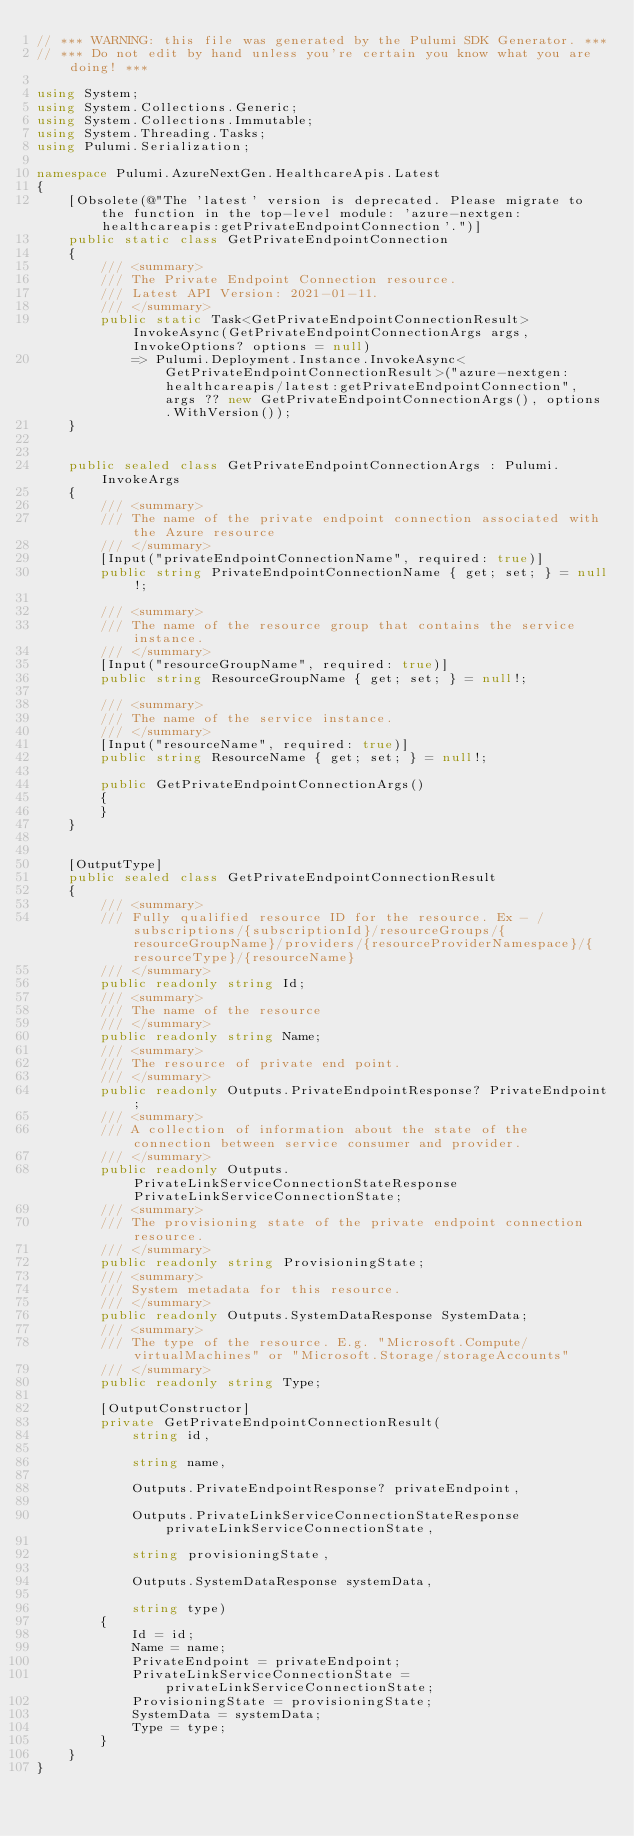<code> <loc_0><loc_0><loc_500><loc_500><_C#_>// *** WARNING: this file was generated by the Pulumi SDK Generator. ***
// *** Do not edit by hand unless you're certain you know what you are doing! ***

using System;
using System.Collections.Generic;
using System.Collections.Immutable;
using System.Threading.Tasks;
using Pulumi.Serialization;

namespace Pulumi.AzureNextGen.HealthcareApis.Latest
{
    [Obsolete(@"The 'latest' version is deprecated. Please migrate to the function in the top-level module: 'azure-nextgen:healthcareapis:getPrivateEndpointConnection'.")]
    public static class GetPrivateEndpointConnection
    {
        /// <summary>
        /// The Private Endpoint Connection resource.
        /// Latest API Version: 2021-01-11.
        /// </summary>
        public static Task<GetPrivateEndpointConnectionResult> InvokeAsync(GetPrivateEndpointConnectionArgs args, InvokeOptions? options = null)
            => Pulumi.Deployment.Instance.InvokeAsync<GetPrivateEndpointConnectionResult>("azure-nextgen:healthcareapis/latest:getPrivateEndpointConnection", args ?? new GetPrivateEndpointConnectionArgs(), options.WithVersion());
    }


    public sealed class GetPrivateEndpointConnectionArgs : Pulumi.InvokeArgs
    {
        /// <summary>
        /// The name of the private endpoint connection associated with the Azure resource
        /// </summary>
        [Input("privateEndpointConnectionName", required: true)]
        public string PrivateEndpointConnectionName { get; set; } = null!;

        /// <summary>
        /// The name of the resource group that contains the service instance.
        /// </summary>
        [Input("resourceGroupName", required: true)]
        public string ResourceGroupName { get; set; } = null!;

        /// <summary>
        /// The name of the service instance.
        /// </summary>
        [Input("resourceName", required: true)]
        public string ResourceName { get; set; } = null!;

        public GetPrivateEndpointConnectionArgs()
        {
        }
    }


    [OutputType]
    public sealed class GetPrivateEndpointConnectionResult
    {
        /// <summary>
        /// Fully qualified resource ID for the resource. Ex - /subscriptions/{subscriptionId}/resourceGroups/{resourceGroupName}/providers/{resourceProviderNamespace}/{resourceType}/{resourceName}
        /// </summary>
        public readonly string Id;
        /// <summary>
        /// The name of the resource
        /// </summary>
        public readonly string Name;
        /// <summary>
        /// The resource of private end point.
        /// </summary>
        public readonly Outputs.PrivateEndpointResponse? PrivateEndpoint;
        /// <summary>
        /// A collection of information about the state of the connection between service consumer and provider.
        /// </summary>
        public readonly Outputs.PrivateLinkServiceConnectionStateResponse PrivateLinkServiceConnectionState;
        /// <summary>
        /// The provisioning state of the private endpoint connection resource.
        /// </summary>
        public readonly string ProvisioningState;
        /// <summary>
        /// System metadata for this resource.
        /// </summary>
        public readonly Outputs.SystemDataResponse SystemData;
        /// <summary>
        /// The type of the resource. E.g. "Microsoft.Compute/virtualMachines" or "Microsoft.Storage/storageAccounts"
        /// </summary>
        public readonly string Type;

        [OutputConstructor]
        private GetPrivateEndpointConnectionResult(
            string id,

            string name,

            Outputs.PrivateEndpointResponse? privateEndpoint,

            Outputs.PrivateLinkServiceConnectionStateResponse privateLinkServiceConnectionState,

            string provisioningState,

            Outputs.SystemDataResponse systemData,

            string type)
        {
            Id = id;
            Name = name;
            PrivateEndpoint = privateEndpoint;
            PrivateLinkServiceConnectionState = privateLinkServiceConnectionState;
            ProvisioningState = provisioningState;
            SystemData = systemData;
            Type = type;
        }
    }
}
</code> 